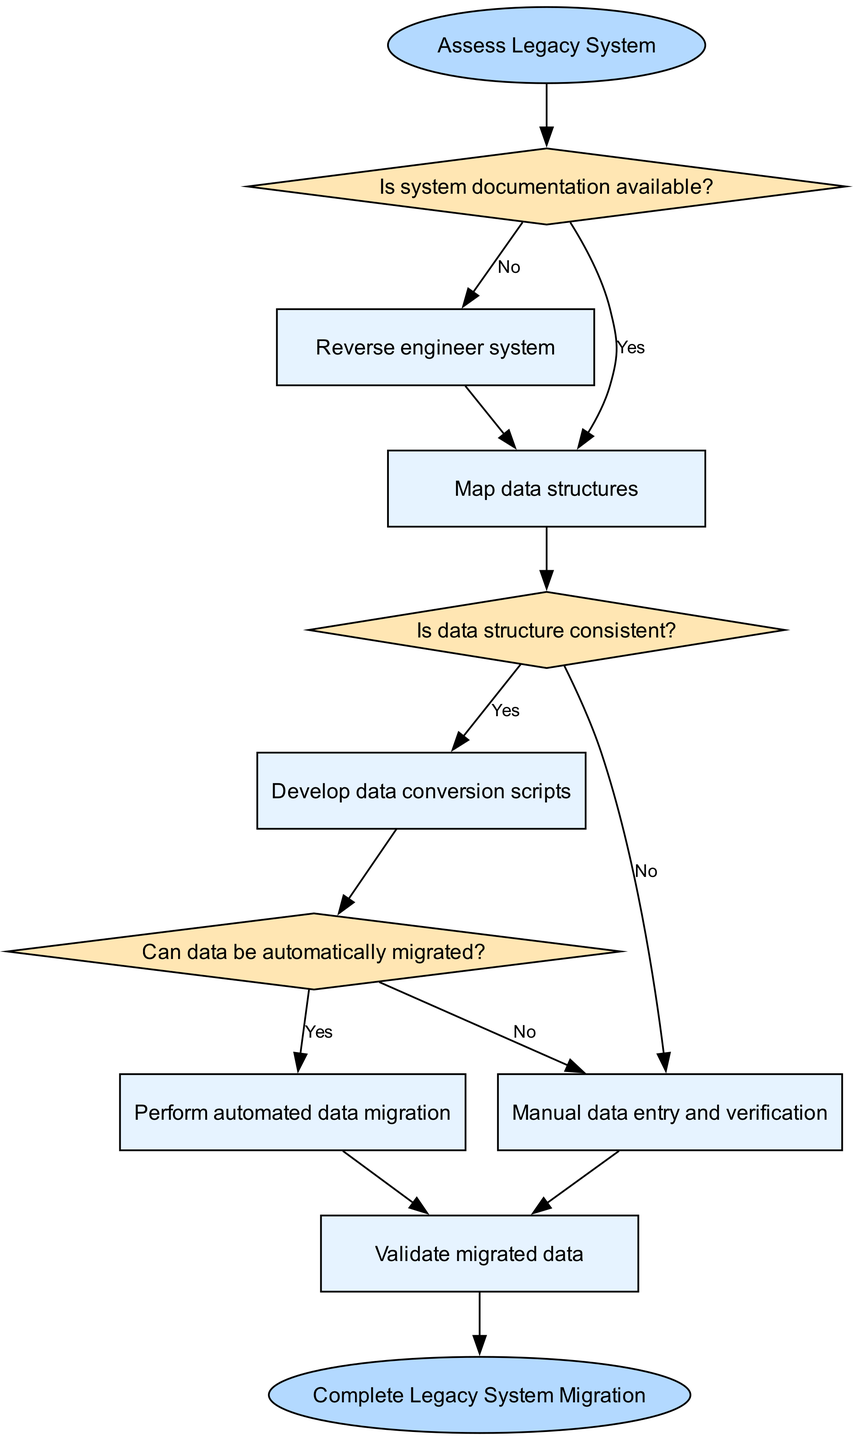What is the starting node of the flowchart? The starting node is clearly labeled as "Assess Legacy System." This can be determined by looking for the ellipse shape node at the beginning of the flowchart.
Answer: Assess Legacy System How many decision nodes are present in the diagram? The diagram contains three decision nodes: "Is system documentation available?", "Is data structure consistent?", and "Can data be automatically migrated?". These can be counted by identifying the diamond-shaped nodes in the flowchart.
Answer: 3 What process follows after "Reverse engineer system"? After the node "Reverse engineer system," the next process is "Map data structures." This can be traced by following the edge from the process node "Reverse engineer system" to the next process in the diagram.
Answer: Map data structures What happens if system documentation is not available? If system documentation is not available, the flowchart indicates to perform "Reverse engineer system." This is derived from the decision node that leads to the process node upon receiving a "No" answer.
Answer: Reverse engineer system What is the next step after validating migrated data? After "Validate migrated data," the flowchart leads to "Complete Legacy System Migration." This is the end node in the diagram that confirms the flow process is complete.
Answer: Complete Legacy System Migration If data structure is inconsistent, what is the subsequent action? If the data structure is inconsistent, the next action required, as represented in the flowchart, is "Manual data entry and verification." This can be traced by following the flow from the decision node with a "No" answer leading to the respective process.
Answer: Manual data entry and verification How is "Perform automated data migration" reached in the flowchart? To reach "Perform automated data migration," the flow moves from the process "Develop data conversion scripts" through the decision "Can data be automatically migrated?" where the answer is "Yes." This involves following the directed edges connecting these nodes.
Answer: Through "Can data be automatically migrated?" with a "Yes" What is the relationship between "Map data structures" and "Is data structure consistent?" "Map data structures" occurs right before the decision node "Is data structure consistent?" and follows the decision node "Is system documentation available?". This indicates that mapping data structures is a prerequisite for determining the consistency of the data structure.
Answer: Preceding the decision node What leads to performing manual data entry and verification? Performing manual data entry and verification is reached if the decision "Is data structure consistent?" returns "No" or if "Can data be automatically migrated?" results in "No." Thus, it's an alternative path stemming from two different decision points.
Answer: If "No" to both decisions 